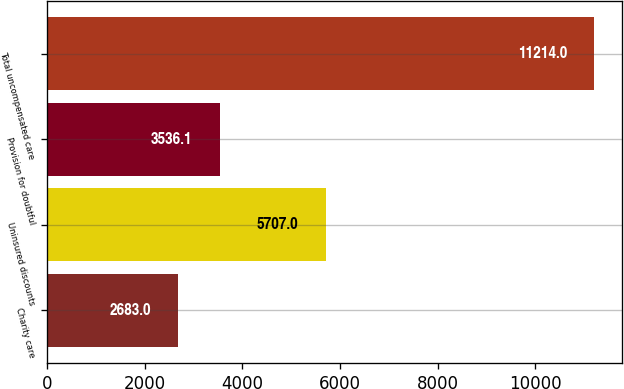<chart> <loc_0><loc_0><loc_500><loc_500><bar_chart><fcel>Charity care<fcel>Uninsured discounts<fcel>Provision for doubtful<fcel>Total uncompensated care<nl><fcel>2683<fcel>5707<fcel>3536.1<fcel>11214<nl></chart> 